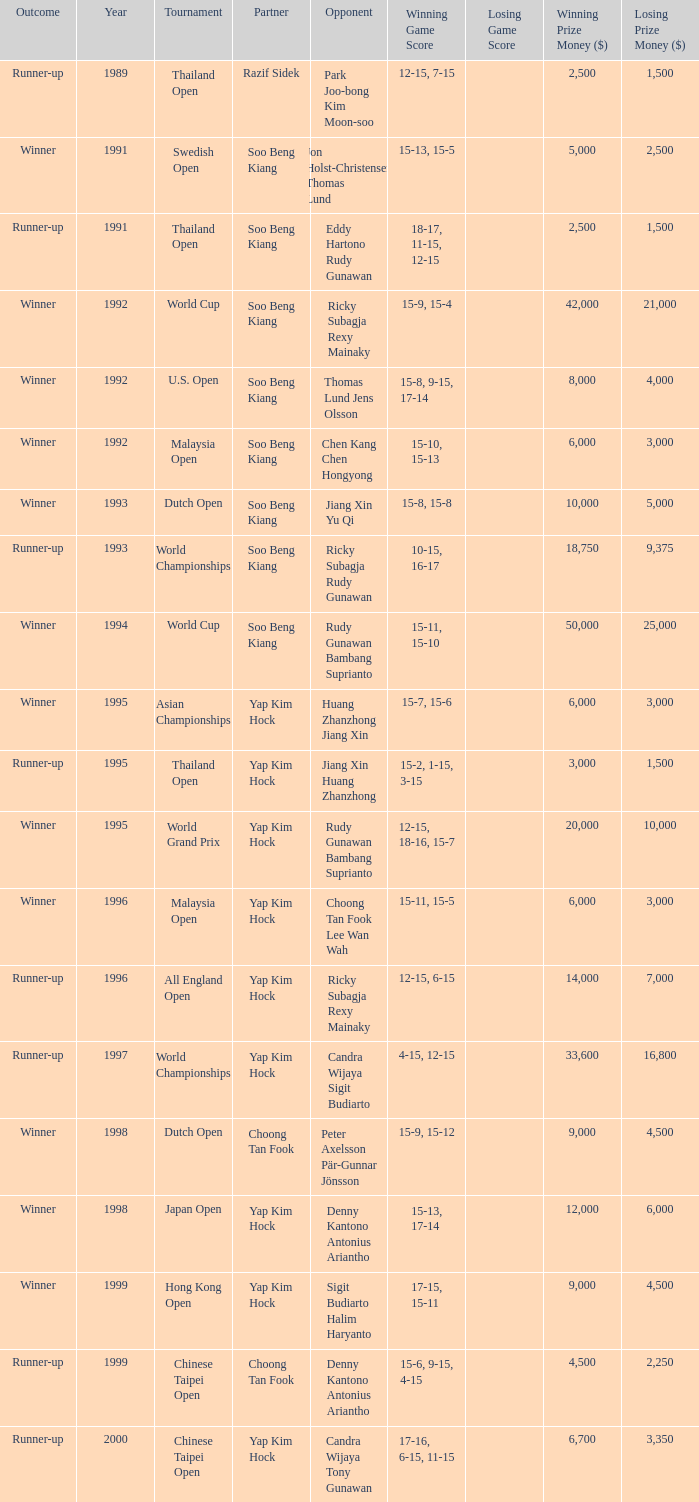Who was Choong Tan Fook's opponent in 1999? Denny Kantono Antonius Ariantho. 